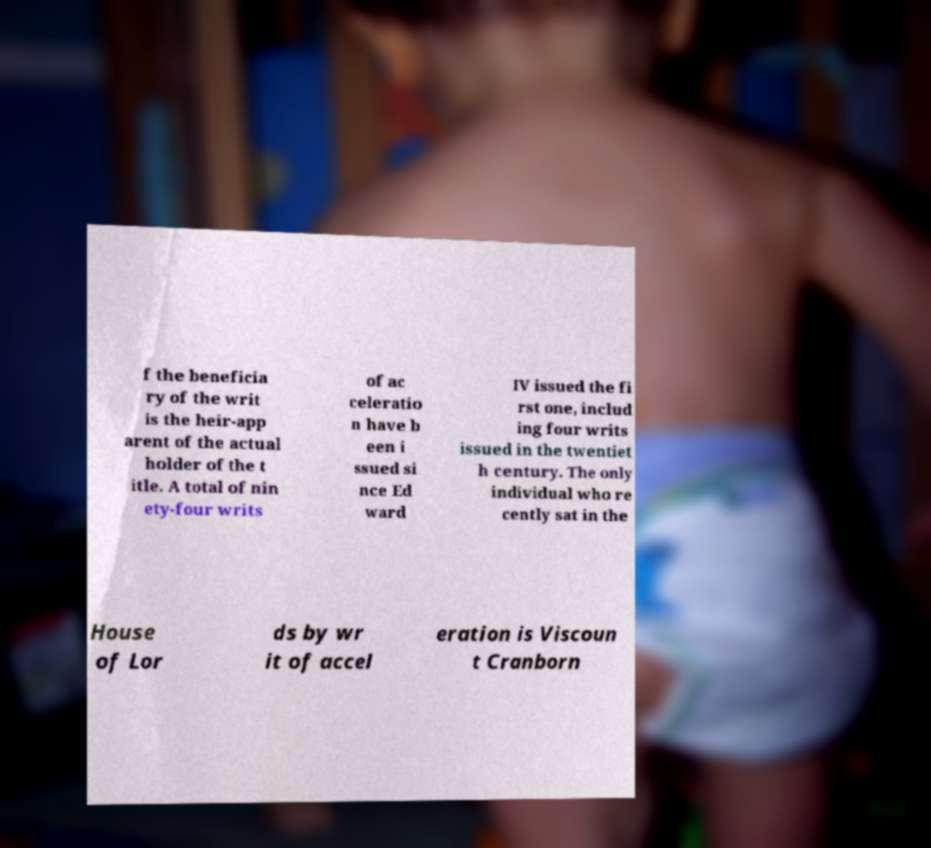What messages or text are displayed in this image? I need them in a readable, typed format. f the beneficia ry of the writ is the heir-app arent of the actual holder of the t itle. A total of nin ety-four writs of ac celeratio n have b een i ssued si nce Ed ward IV issued the fi rst one, includ ing four writs issued in the twentiet h century. The only individual who re cently sat in the House of Lor ds by wr it of accel eration is Viscoun t Cranborn 